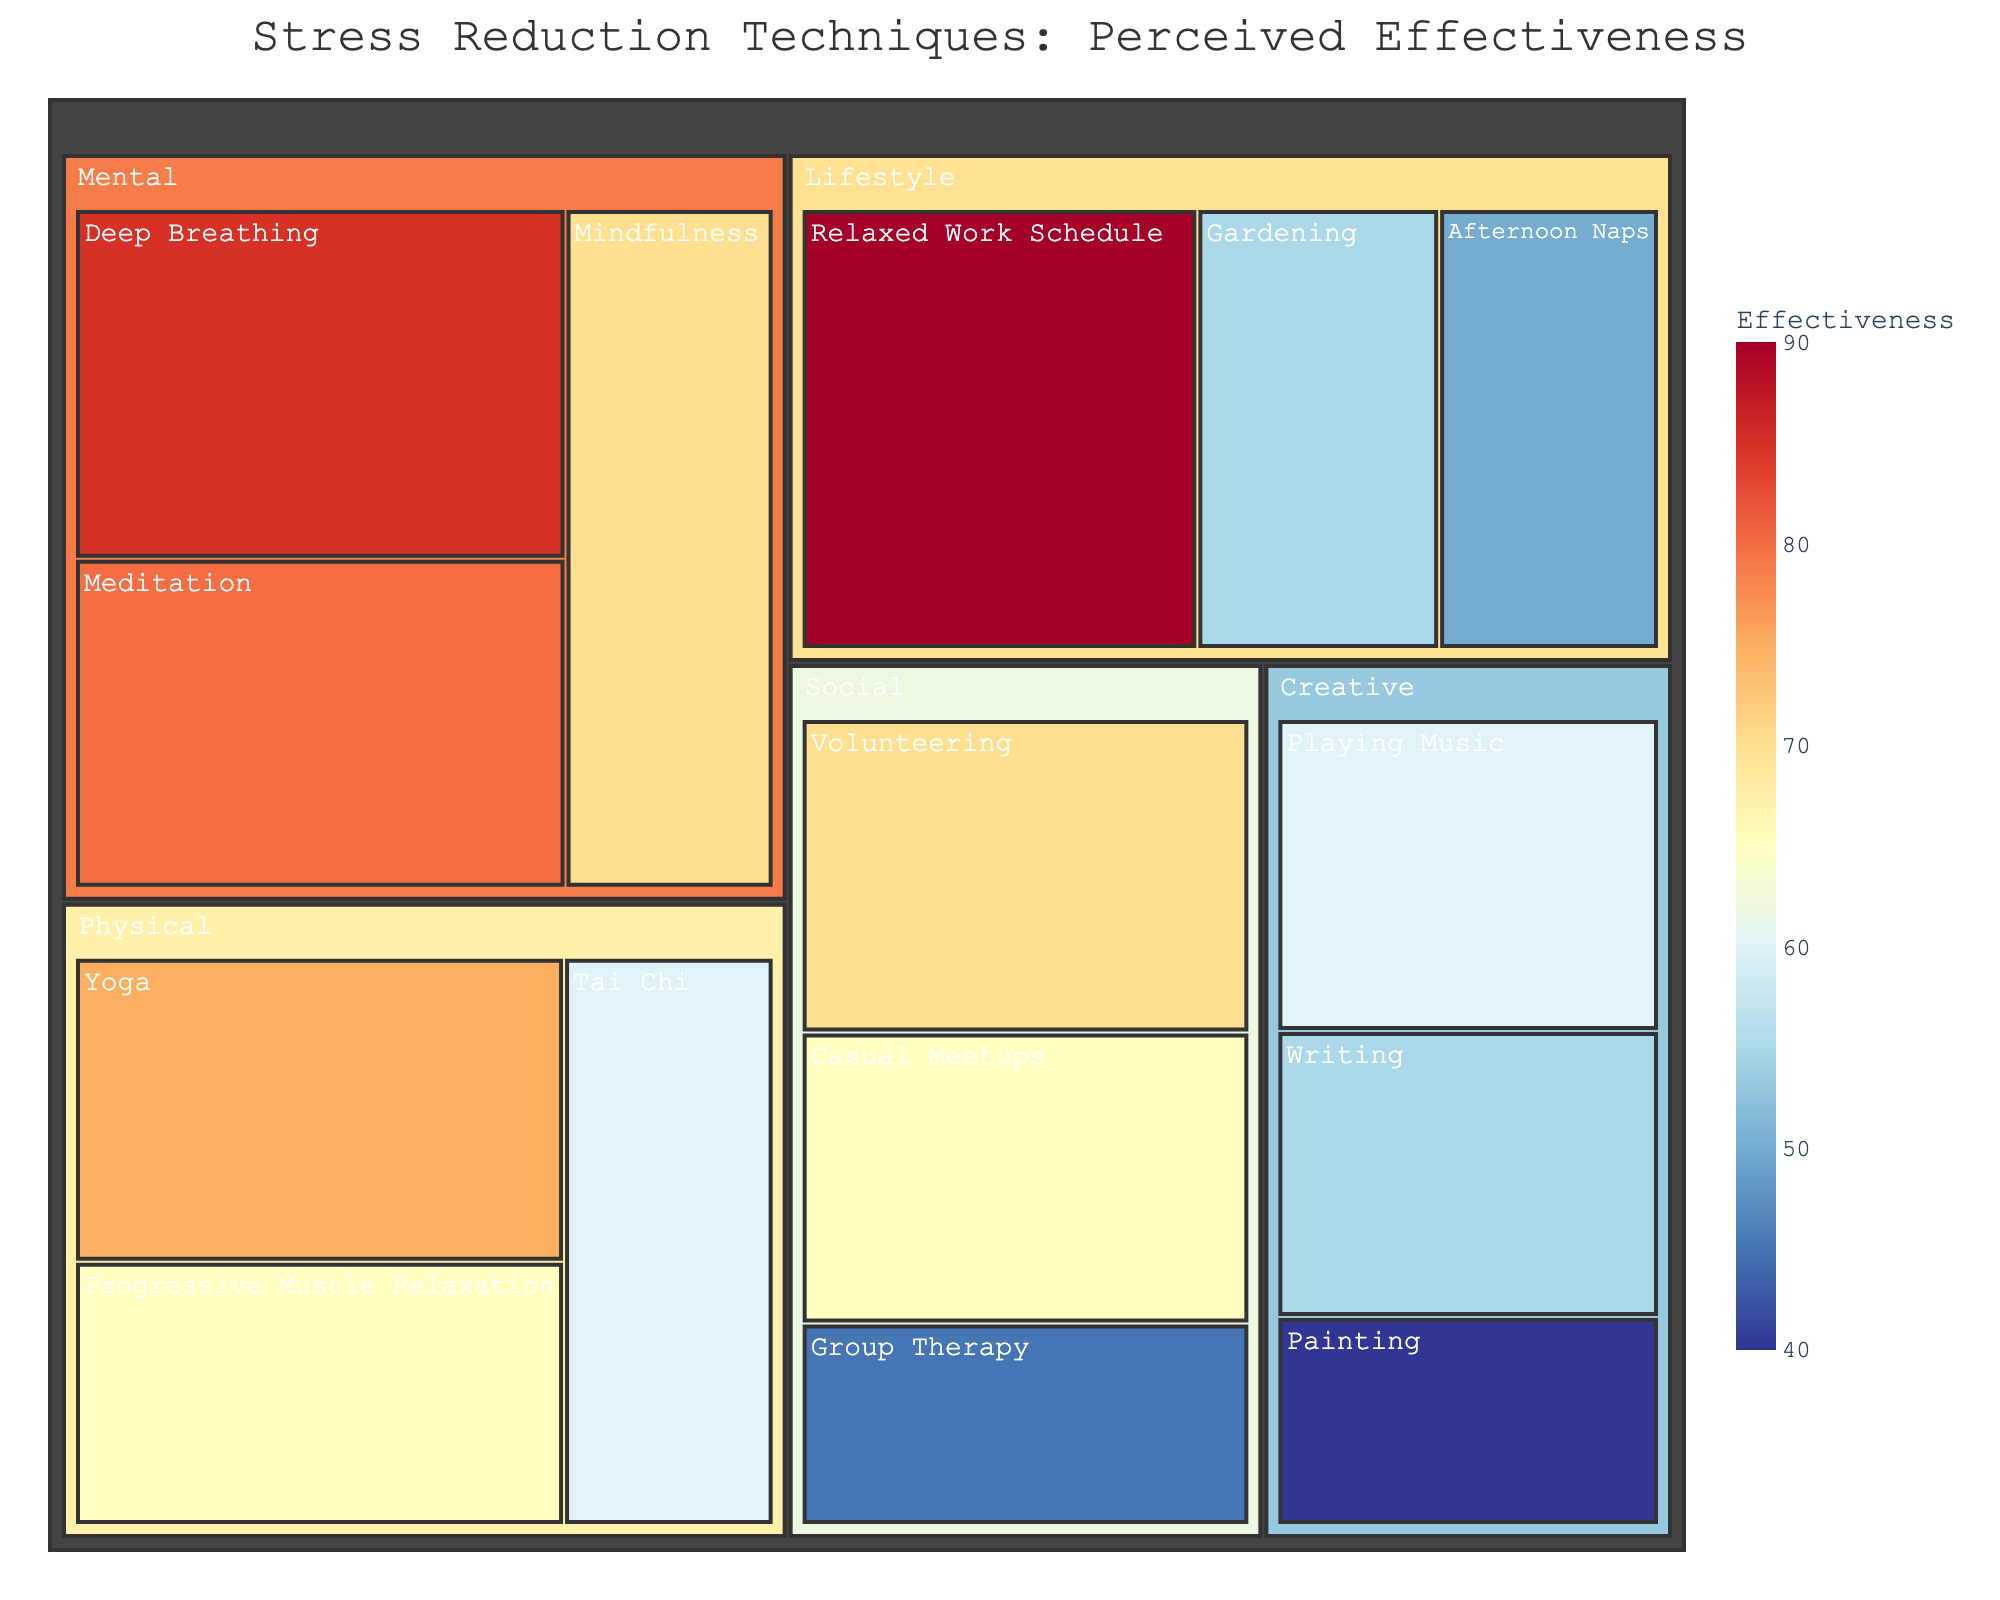What is the title of the figure? The title is prominently displayed at the top of the figure.
Answer: Stress Reduction Techniques: Perceived Effectiveness Which technique has the highest perceived effectiveness? Look for the largest box with the darkest blue color and highest effectiveness value.
Answer: Relaxed Work Schedule What category does 'Deep Breathing' fall under and what is its perceived effectiveness? Find 'Deep Breathing' within the treemap and check the associated category and effectiveness value.
Answer: Mental, 85 How many techniques are listed under the 'Lifestyle' category? Count the number of boxes within the 'Lifestyle' section of the treemap.
Answer: 3 What is the average perceived effectiveness of techniques under the 'Creative' category? Sum the effectiveness values of 'Painting', 'Playing Music', and 'Writing' and divide by 3.
Answer: (40 + 60 + 55) / 3 = 51.67 Which category has the lowest average perceived effectiveness? Compute the average of effectiveness for each category and compare.
Answer: Social Compare the perceived effectiveness of 'Yoga' and 'Group Therapy'. Which one is higher? Check the effectiveness values of 'Yoga' and 'Group Therapy' in their respective categories.
Answer: Yoga (75) > Group Therapy (45) What technique has the lowest perceived effectiveness and which category does it belong to? Identify the smallest box with the lightest color and lowest value.
Answer: Painting, Creative What is the combined perceived effectiveness of all techniques in the 'Physical' category? Sum the values of 'Yoga', 'Tai Chi', and 'Progressive Muscle Relaxation'.
Answer: 75 + 60 + 65 = 200 Which category has the most techniques listed? Count the techniques within each category.
Answer: Creative 